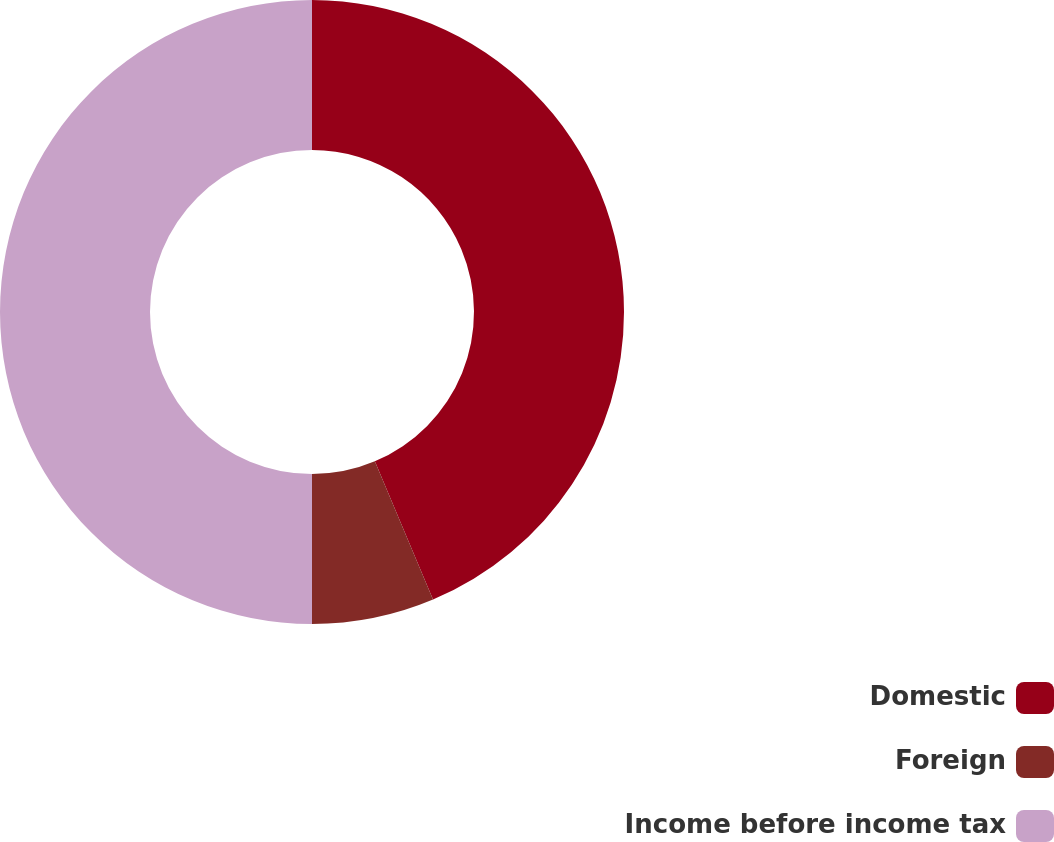Convert chart to OTSL. <chart><loc_0><loc_0><loc_500><loc_500><pie_chart><fcel>Domestic<fcel>Foreign<fcel>Income before income tax<nl><fcel>43.66%<fcel>6.34%<fcel>50.0%<nl></chart> 